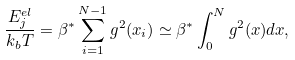<formula> <loc_0><loc_0><loc_500><loc_500>\frac { E ^ { e l } _ { j } } { k _ { b } T } = \beta ^ { * } \sum _ { i = 1 } ^ { N - 1 } g ^ { 2 } ( x _ { i } ) \simeq \beta ^ { * } \int _ { 0 } ^ { N } g ^ { 2 } ( x ) d x ,</formula> 